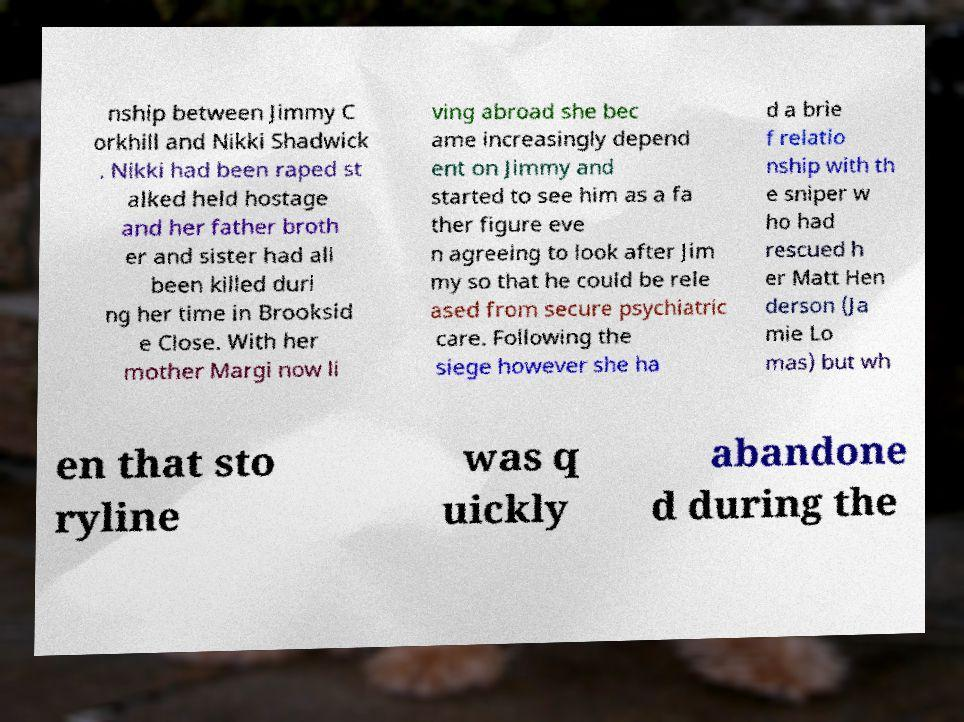Could you extract and type out the text from this image? nship between Jimmy C orkhill and Nikki Shadwick . Nikki had been raped st alked held hostage and her father broth er and sister had all been killed duri ng her time in Brooksid e Close. With her mother Margi now li ving abroad she bec ame increasingly depend ent on Jimmy and started to see him as a fa ther figure eve n agreeing to look after Jim my so that he could be rele ased from secure psychiatric care. Following the siege however she ha d a brie f relatio nship with th e sniper w ho had rescued h er Matt Hen derson (Ja mie Lo mas) but wh en that sto ryline was q uickly abandone d during the 